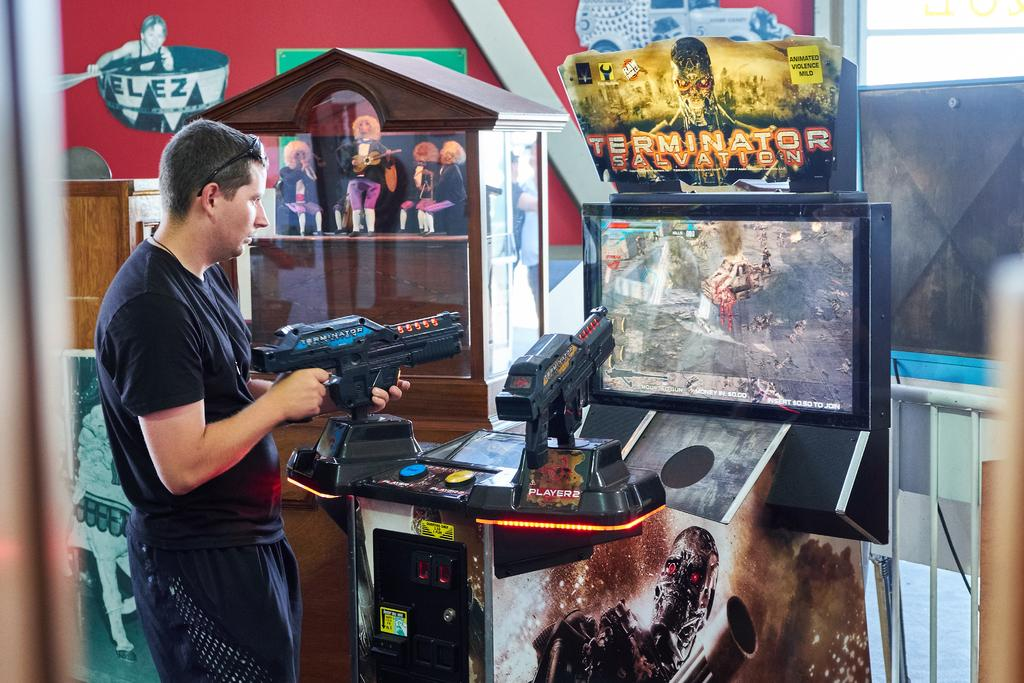What can be seen in the background of the image? There is a screen and posters visible in the background of the image. Who is present in the image? There is a man in the image. What is the man wearing? The man is wearing a black t-shirt. What type of accessory can be seen in the image? There are goggles visible in the image. What type of wine is being served at the event in the image? There is no event or wine present in the image; it features a man wearing a black t-shirt and goggles in front of a screen and posters. What color is the powder that is being used in the image? There is no powder present in the image. 